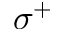<formula> <loc_0><loc_0><loc_500><loc_500>\sigma ^ { + }</formula> 